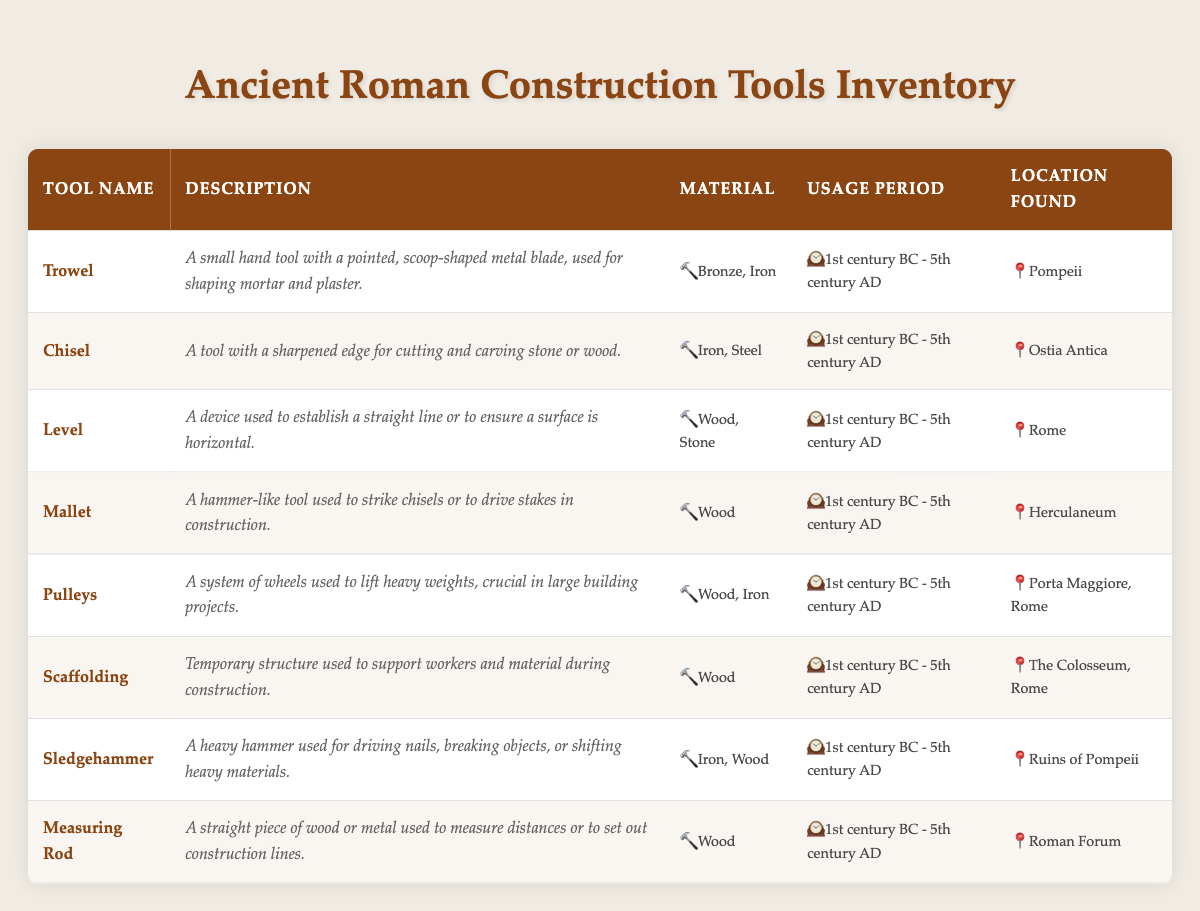What materials were used to make the Trowel? According to the table, the Trowel was made using Bronze and Iron.
Answer: Bronze, Iron Which tool was used for establishing a straight line or ensuring a horizontal surface? The tool that serves this purpose is the Level, as indicated in the description column of the table.
Answer: Level Is the usage period for all tools in the inventory the same? Yes, all tools mentioned in the inventory have the same usage period, which is from the 1st century BC to the 5th century AD.
Answer: Yes What locations were tools found in Pompeii? The table lists two tools found in Pompeii: the Trowel and the Sledgehammer, as specified in their 'location found' entries.
Answer: Trowel, Sledgehammer How many tools were made of Wood? By examining the material column, we see that four tools (Level, Mallet, Scaffolding, Measuring Rod) are made of Wood.
Answer: 4 What is the combined total of materials made from Iron? The tools made from Iron are the Chisel, Pulleys, Sledgehammer, and Trowel. The total materials are Iron + Iron + Iron + Iron = 4 Iron.
Answer: 4 Iron Did any tools utilize both Wood and Iron materials? Yes, the Pulleys and Sledgehammer are the tools that incorporate both Wood and Iron materials according to the materials listed in the table.
Answer: Yes Which tool was specifically found at the Colosseum in Rome? The tool found specifically at the Colosseum in Rome is Scaffolding, as stated in the location found column.
Answer: Scaffolding What tool had the longest and most complex description? By comparing the descriptions in the table, the Pulleys have the most detailed description, explaining the function in building projects.
Answer: Pulleys 